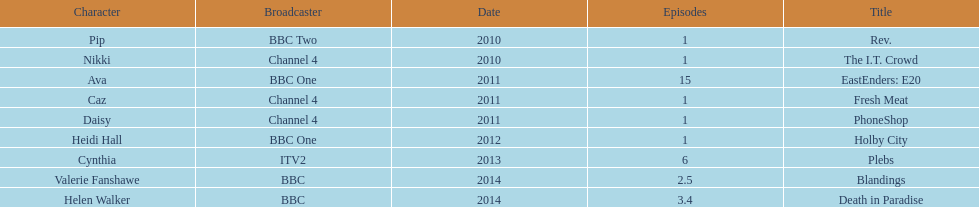Blandings and death in paradise both aired on which broadcaster? BBC. Help me parse the entirety of this table. {'header': ['Character', 'Broadcaster', 'Date', 'Episodes', 'Title'], 'rows': [['Pip', 'BBC Two', '2010', '1', 'Rev.'], ['Nikki', 'Channel 4', '2010', '1', 'The I.T. Crowd'], ['Ava', 'BBC One', '2011', '15', 'EastEnders: E20'], ['Caz', 'Channel 4', '2011', '1', 'Fresh Meat'], ['Daisy', 'Channel 4', '2011', '1', 'PhoneShop'], ['Heidi Hall', 'BBC One', '2012', '1', 'Holby City'], ['Cynthia', 'ITV2', '2013', '6', 'Plebs'], ['Valerie Fanshawe', 'BBC', '2014', '2.5', 'Blandings'], ['Helen Walker', 'BBC', '2014', '3.4', 'Death in Paradise']]} 